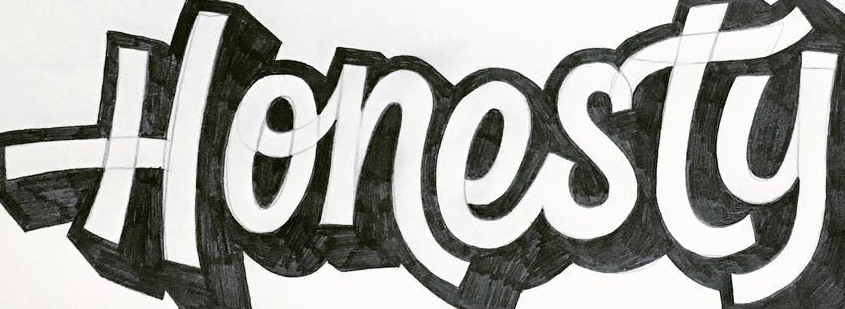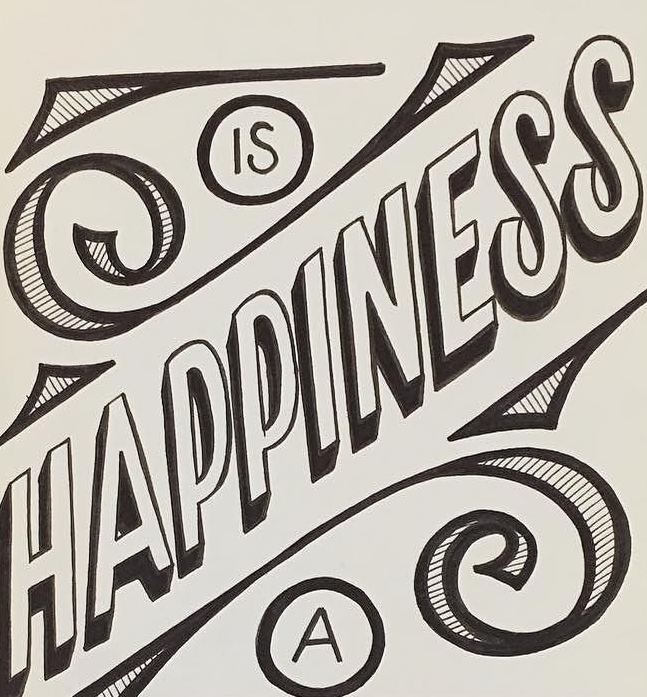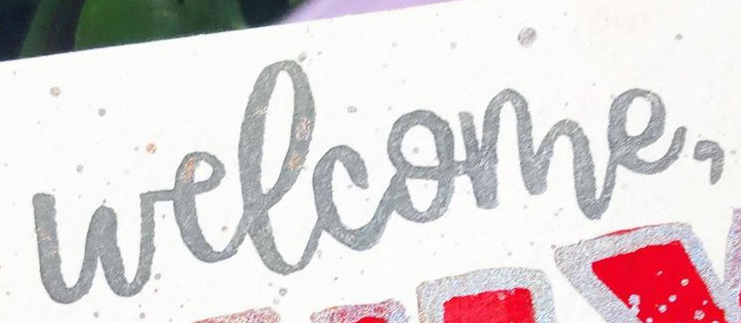What words are shown in these images in order, separated by a semicolon? Honesty; HAPPINESS; welcome, 